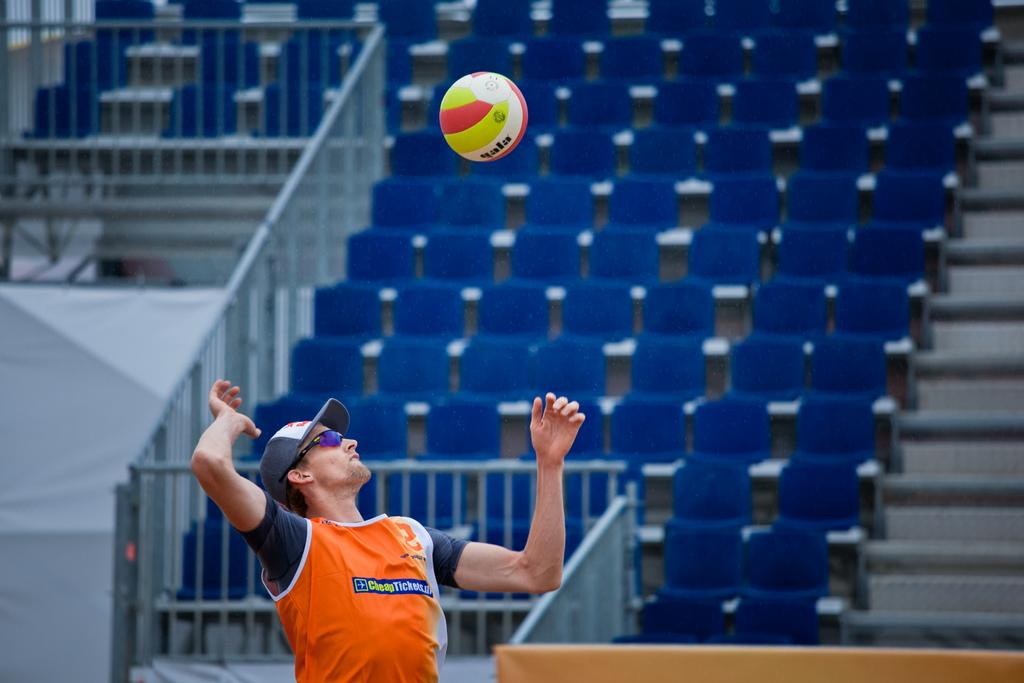What is the man in the image doing? The man is trying to hit a ball in the image. Can you describe the setting of the image? There is a railing and chairs in the background of the image. What color is the vest the man is wearing in the image? There is no mention of a vest in the image, so we cannot determine its color. 